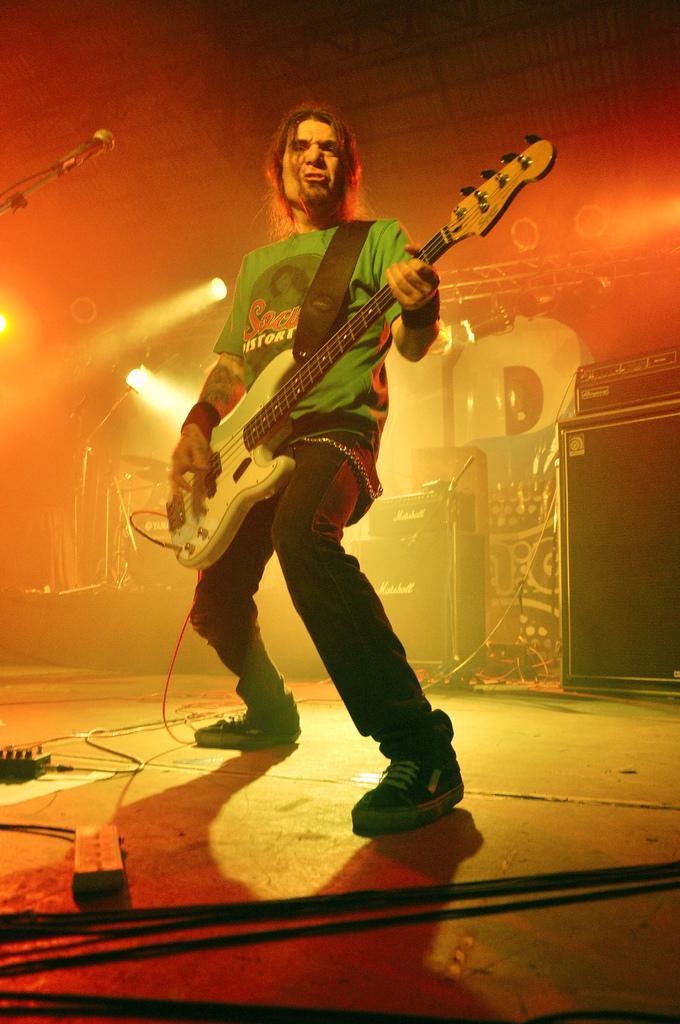Describe this image in one or two sentences. As we can see in the image there is a mic, light and a man holding guitar. 